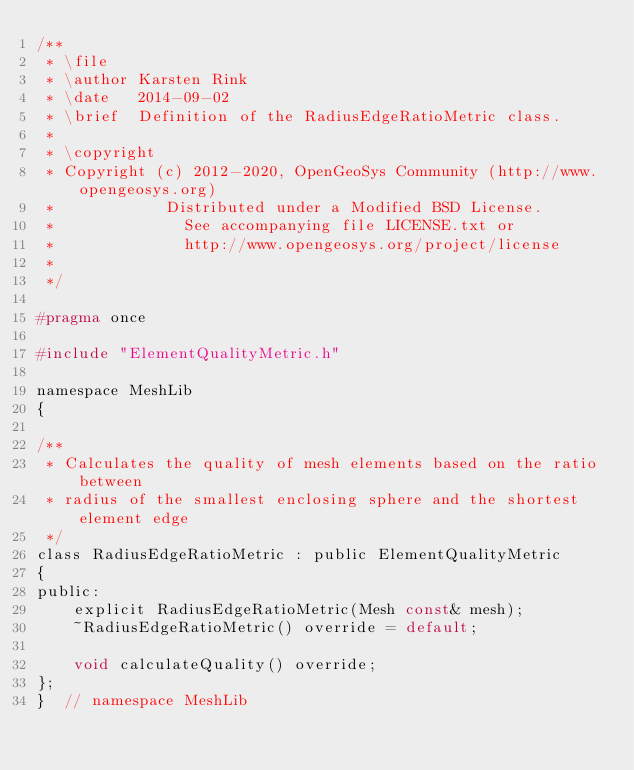Convert code to text. <code><loc_0><loc_0><loc_500><loc_500><_C_>/**
 * \file
 * \author Karsten Rink
 * \date   2014-09-02
 * \brief  Definition of the RadiusEdgeRatioMetric class.
 *
 * \copyright
 * Copyright (c) 2012-2020, OpenGeoSys Community (http://www.opengeosys.org)
 *            Distributed under a Modified BSD License.
 *              See accompanying file LICENSE.txt or
 *              http://www.opengeosys.org/project/license
 *
 */

#pragma once

#include "ElementQualityMetric.h"

namespace MeshLib
{

/**
 * Calculates the quality of mesh elements based on the ratio between
 * radius of the smallest enclosing sphere and the shortest element edge
 */
class RadiusEdgeRatioMetric : public ElementQualityMetric
{
public:
    explicit RadiusEdgeRatioMetric(Mesh const& mesh);
    ~RadiusEdgeRatioMetric() override = default;

    void calculateQuality() override;
};
}  // namespace MeshLib
</code> 